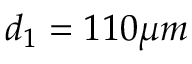Convert formula to latex. <formula><loc_0><loc_0><loc_500><loc_500>d _ { 1 } = 1 1 0 \mu m</formula> 